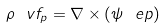Convert formula to latex. <formula><loc_0><loc_0><loc_500><loc_500>\rho \ v f _ { p } = \nabla \times ( \psi \ e p )</formula> 